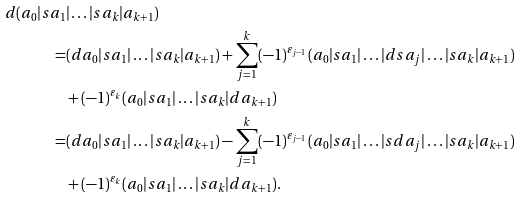<formula> <loc_0><loc_0><loc_500><loc_500>d ( a _ { 0 } | s a _ { 1 } & | \dots | s a _ { k } | a _ { k + 1 } ) \\ = & ( d a _ { 0 } | s a _ { 1 } | \dots | s a _ { k } | a _ { k + 1 } ) + \sum _ { j = 1 } ^ { k } ( - 1 ) ^ { \varepsilon _ { j - 1 } } ( a _ { 0 } | s a _ { 1 } | \dots | d s a _ { j } | \dots | s a _ { k } | a _ { k + 1 } ) \\ & + ( - 1 ) ^ { \varepsilon _ { k } } ( a _ { 0 } | s a _ { 1 } | \dots | s a _ { k } | d a _ { k + 1 } ) \\ = & ( d a _ { 0 } | s a _ { 1 } | \dots | s a _ { k } | a _ { k + 1 } ) - \sum _ { j = 1 } ^ { k } ( - 1 ) ^ { \varepsilon _ { j - 1 } } ( a _ { 0 } | s a _ { 1 } | \dots | s d a _ { j } | \dots | s a _ { k } | a _ { k + 1 } ) \\ & + ( - 1 ) ^ { \varepsilon _ { k } } ( a _ { 0 } | s a _ { 1 } | \dots | s a _ { k } | d a _ { k + 1 } ) .</formula> 